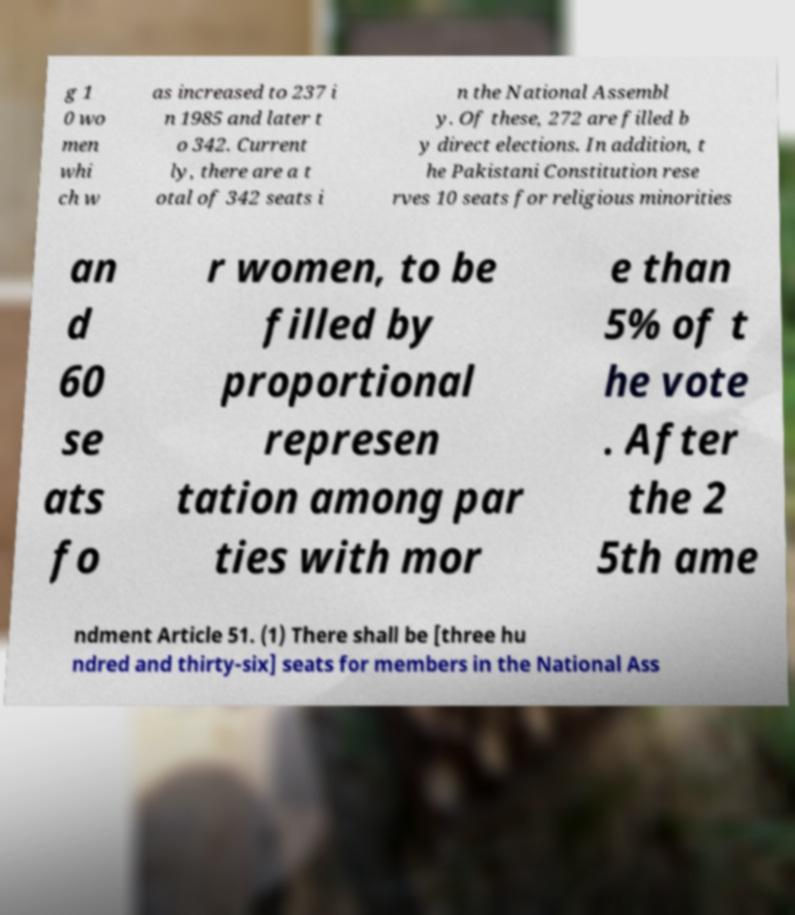Can you read and provide the text displayed in the image?This photo seems to have some interesting text. Can you extract and type it out for me? g 1 0 wo men whi ch w as increased to 237 i n 1985 and later t o 342. Current ly, there are a t otal of 342 seats i n the National Assembl y. Of these, 272 are filled b y direct elections. In addition, t he Pakistani Constitution rese rves 10 seats for religious minorities an d 60 se ats fo r women, to be filled by proportional represen tation among par ties with mor e than 5% of t he vote . After the 2 5th ame ndment Article 51. (1) There shall be [three hu ndred and thirty-six] seats for members in the National Ass 